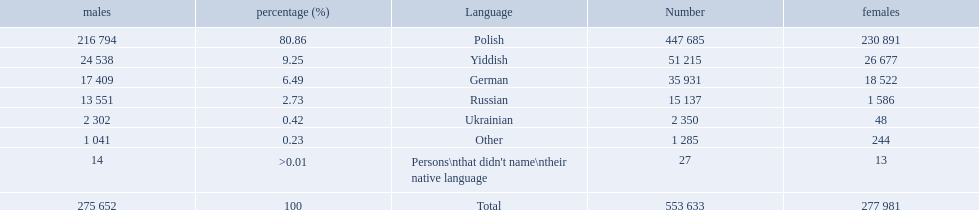Which language options are listed? Polish, Yiddish, German, Russian, Ukrainian, Other, Persons\nthat didn't name\ntheir native language. Of these, which did .42% of the people select? Ukrainian. 